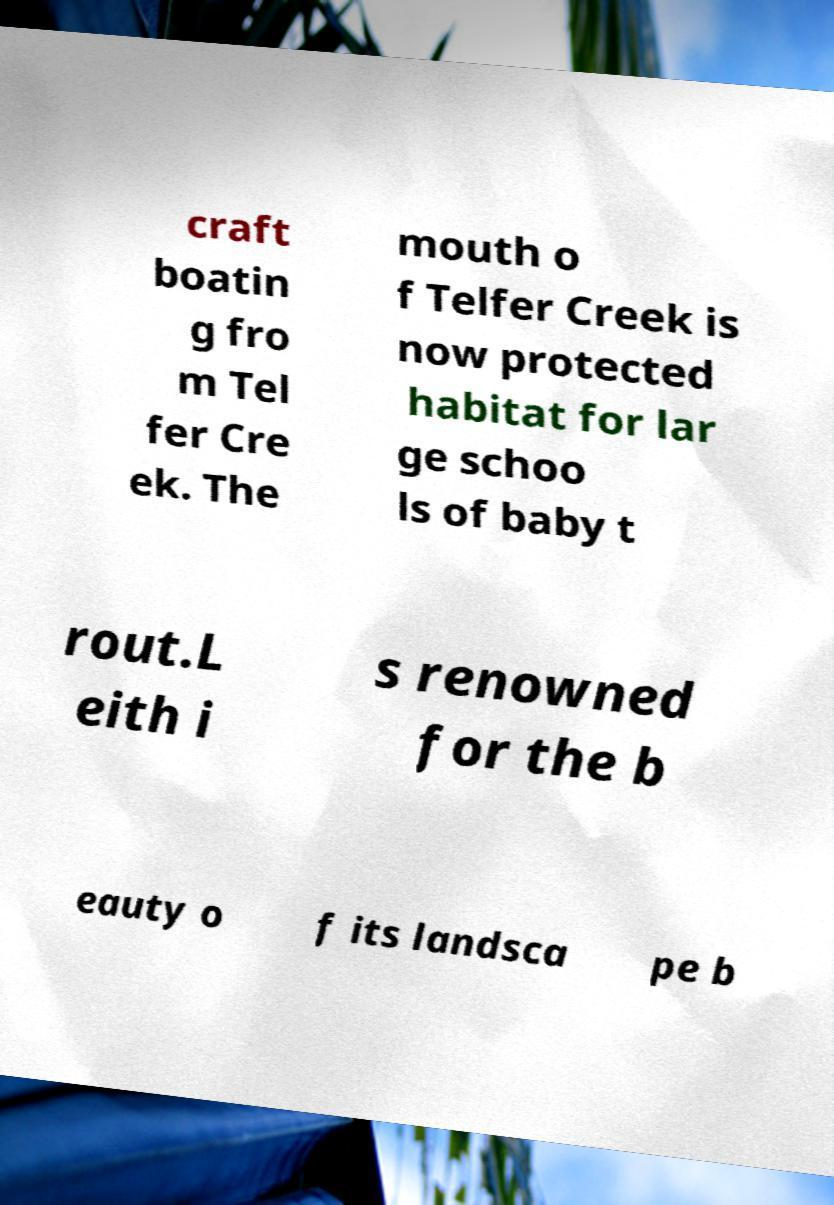I need the written content from this picture converted into text. Can you do that? craft boatin g fro m Tel fer Cre ek. The mouth o f Telfer Creek is now protected habitat for lar ge schoo ls of baby t rout.L eith i s renowned for the b eauty o f its landsca pe b 